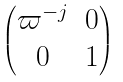<formula> <loc_0><loc_0><loc_500><loc_500>\begin{pmatrix} \varpi ^ { - j } & 0 \\ 0 & 1 \end{pmatrix}</formula> 